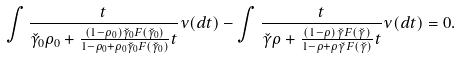<formula> <loc_0><loc_0><loc_500><loc_500>\int \frac { t } { \check { \gamma } _ { 0 } \rho _ { 0 } + \frac { ( 1 - \rho _ { 0 } ) \check { \gamma } _ { 0 } F ( \check { \gamma } _ { 0 } ) } { 1 - \rho _ { 0 } + \rho _ { 0 } \check { \gamma } _ { 0 } F ( \check { \gamma } _ { 0 } ) } t } \nu ( d t ) - \int \frac { t } { \check { \gamma } \rho + \frac { ( 1 - \rho ) \check { \gamma } F ( \check { \gamma } ) } { 1 - \rho + \rho \check { \gamma } F ( \check { \gamma } ) } t } \nu ( d t ) & = 0 .</formula> 